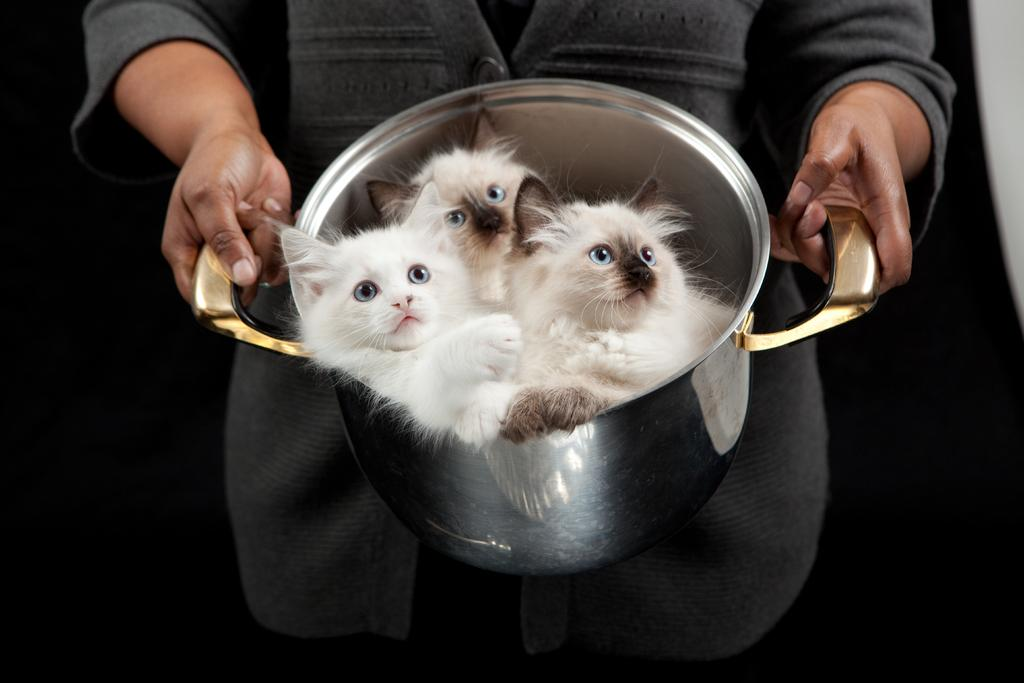Who or what is the main subject of the image? There is a person in the image. What is the person holding in the image? The person is holding a container. What can be found inside the container? There are three cats in the container. Can you describe the background of the image? The background of the image is dark. Is the woman in the image taking a recess from her acting job? There is no woman or acting job mentioned in the image. The image only features a person holding a container with three cats inside, and the background is dark. 